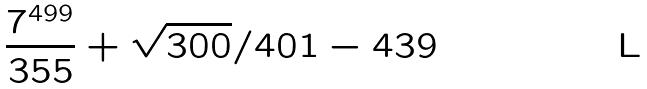Convert formula to latex. <formula><loc_0><loc_0><loc_500><loc_500>\frac { 7 ^ { 4 9 9 } } { 3 5 5 } + \sqrt { 3 0 0 } / 4 0 1 - 4 3 9</formula> 